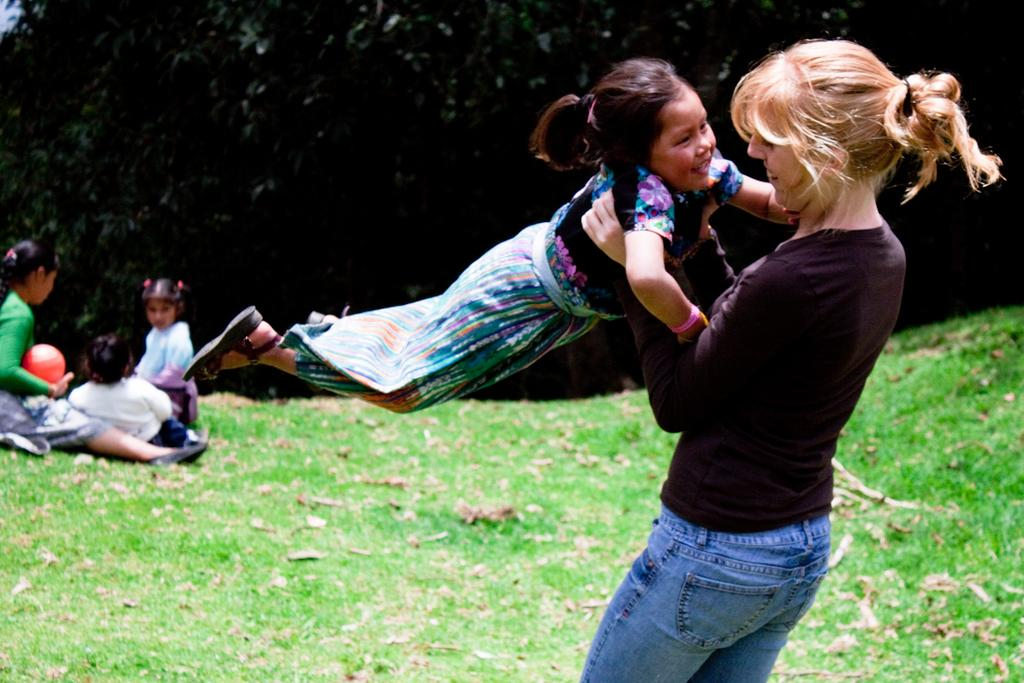What is the woman doing in the image? The woman is holding a girl in the image. Where are the woman and girl standing? They are standing on grassland. What are the kids doing on the grassland? Kids are sitting on the grassland. What is the girl holding in the image? The girl is holding a ball. What can be seen in the background of the image? There are trees in the background of the image. What type of feast is being prepared on the grassland in the image? There is no indication of a feast being prepared in the image; it primarily features people and a ball. 